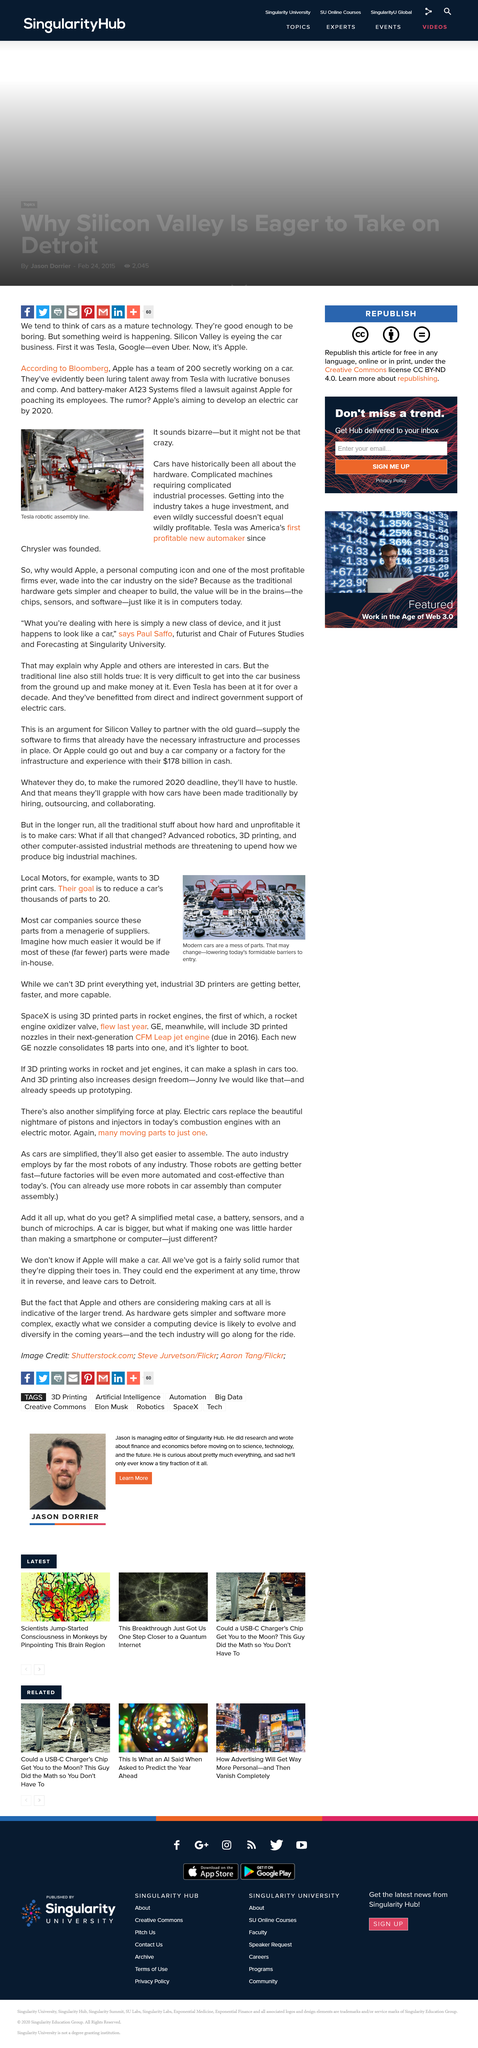Outline some significant characteristics in this image. A123 Systems filed a lawsuit against Apple for poaching employees. The image depicts a Tesla robotic assembly line in action, demonstrating the automation and efficiency of the manufacturing process. Silicon Valley companies such as Tesla, Google, Uber, and Apple are all eyeing the car business and considering entering the market. Local Motors aims to produce vehicles through 3D printing technology, while SpaceX has implemented 3D printed parts in the engines of its rockets to enhance their functionality and durability. The new GE nozzle consolidates 18 parts into one, reducing the overall number of parts needed for a given task. 